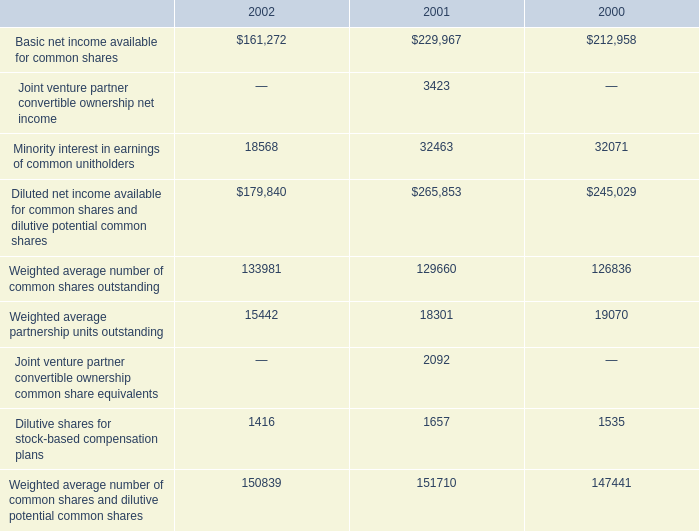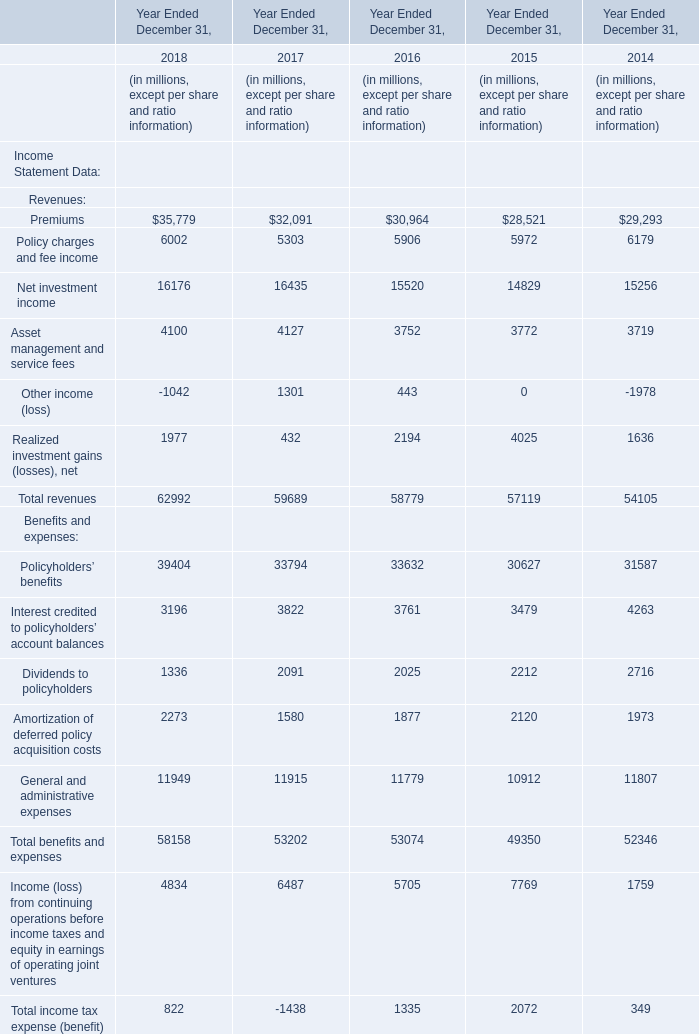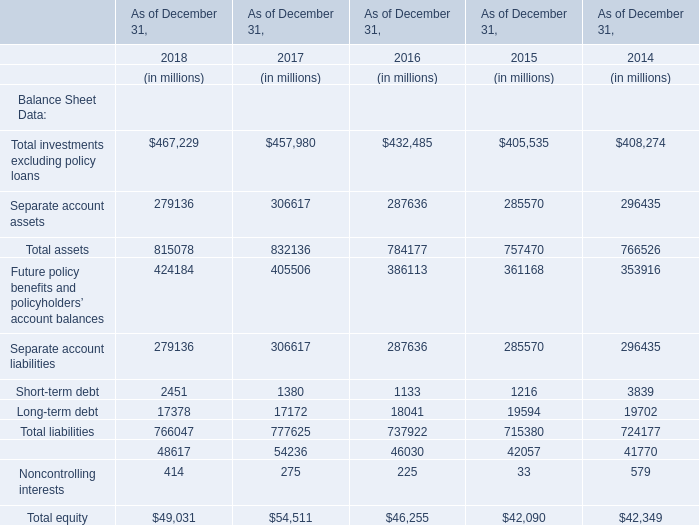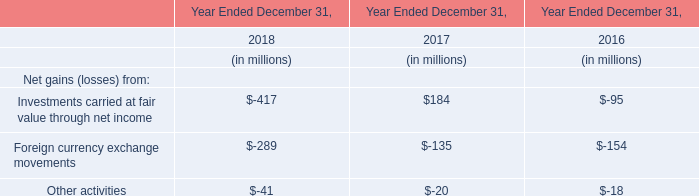What do all Balance Sheet Data sum up without those Balance Sheet Data smaller than 400000, in 2018 for As of December 31, ? (in million) 
Computations: (((467229 + 815078) + 424184) + 766047)
Answer: 2472538.0. 